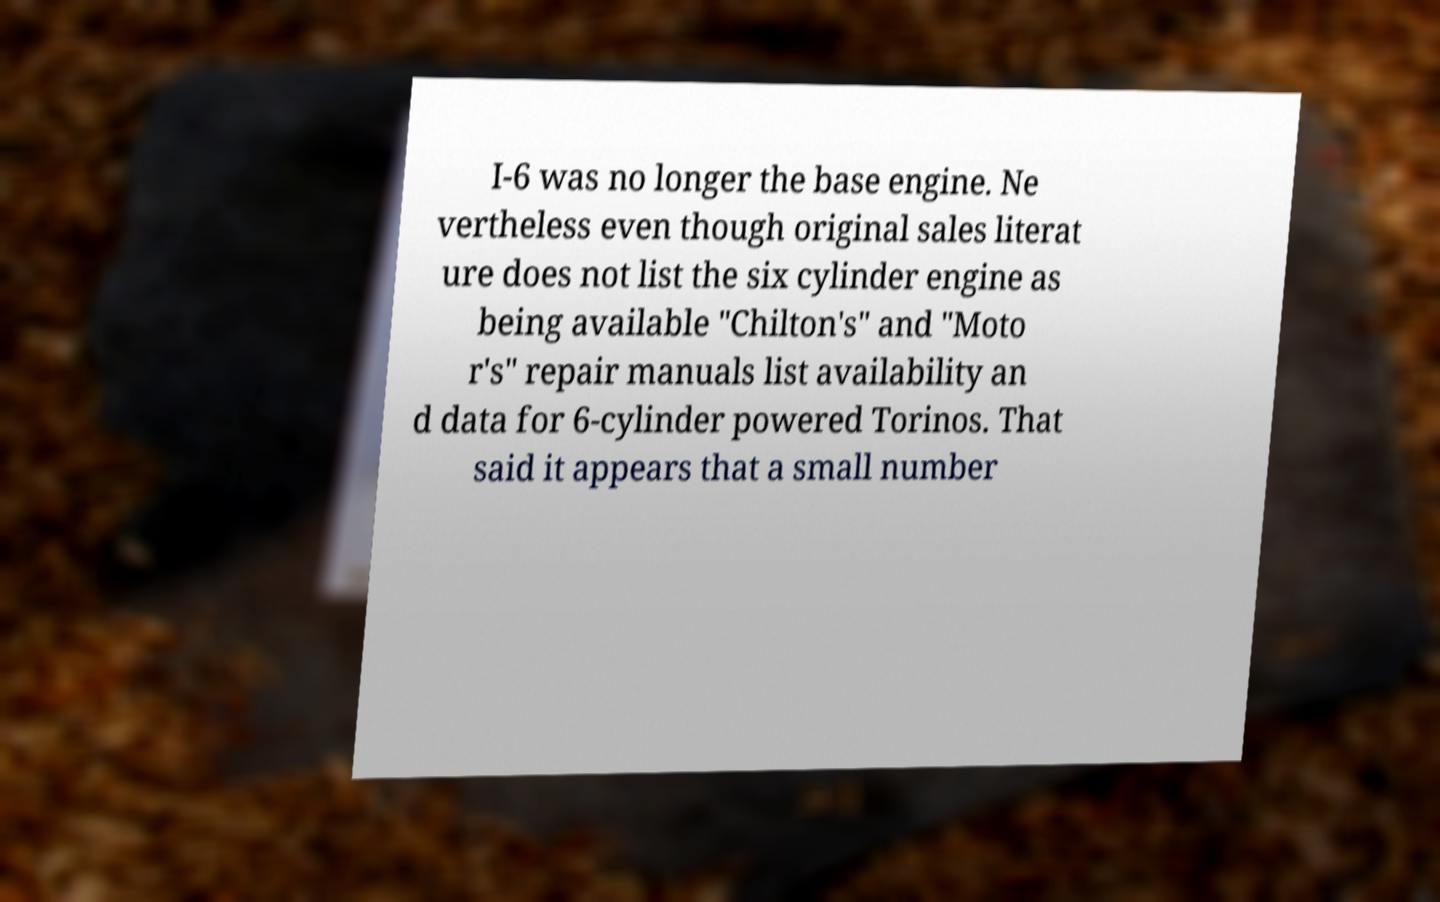Can you accurately transcribe the text from the provided image for me? I-6 was no longer the base engine. Ne vertheless even though original sales literat ure does not list the six cylinder engine as being available "Chilton's" and "Moto r's" repair manuals list availability an d data for 6-cylinder powered Torinos. That said it appears that a small number 